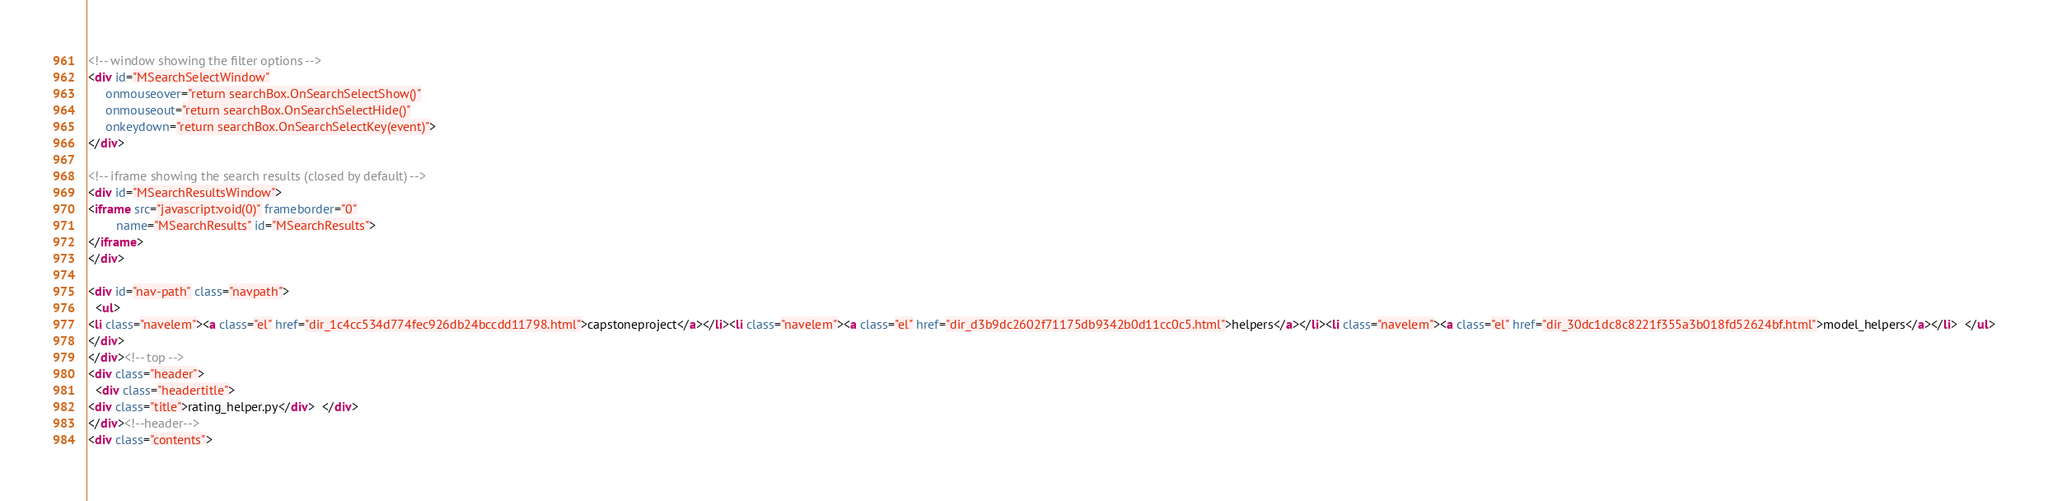Convert code to text. <code><loc_0><loc_0><loc_500><loc_500><_HTML_><!-- window showing the filter options -->
<div id="MSearchSelectWindow"
     onmouseover="return searchBox.OnSearchSelectShow()"
     onmouseout="return searchBox.OnSearchSelectHide()"
     onkeydown="return searchBox.OnSearchSelectKey(event)">
</div>

<!-- iframe showing the search results (closed by default) -->
<div id="MSearchResultsWindow">
<iframe src="javascript:void(0)" frameborder="0" 
        name="MSearchResults" id="MSearchResults">
</iframe>
</div>

<div id="nav-path" class="navpath">
  <ul>
<li class="navelem"><a class="el" href="dir_1c4cc534d774fec926db24bccdd11798.html">capstoneproject</a></li><li class="navelem"><a class="el" href="dir_d3b9dc2602f71175db9342b0d11cc0c5.html">helpers</a></li><li class="navelem"><a class="el" href="dir_30dc1dc8c8221f355a3b018fd52624bf.html">model_helpers</a></li>  </ul>
</div>
</div><!-- top -->
<div class="header">
  <div class="headertitle">
<div class="title">rating_helper.py</div>  </div>
</div><!--header-->
<div class="contents"></code> 